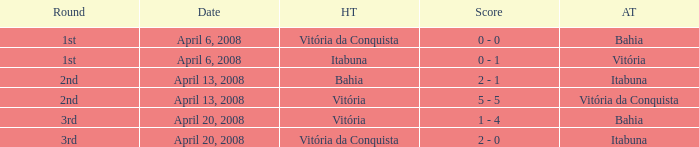What is the name of the home team with a round of 2nd and Vitória da Conquista as the way team? Vitória. 